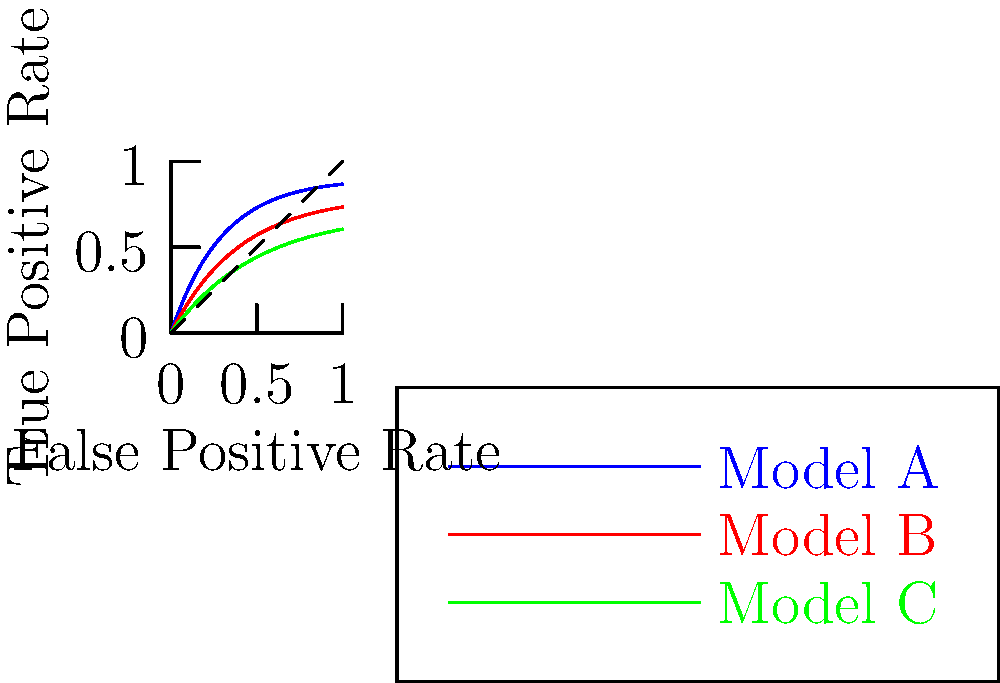Based on the ROC curves shown for three machine learning models (A, B, and C) used in nanomaterial property prediction, which model demonstrates the best overall performance? To determine the best performing model based on ROC curves, we need to follow these steps:

1. Understand ROC curves:
   - ROC curves plot the True Positive Rate (TPR) against the False Positive Rate (FPR).
   - The diagonal line represents random guessing.
   - Curves closer to the top-left corner indicate better performance.

2. Analyze Area Under the Curve (AUC):
   - AUC is a measure of the model's overall performance.
   - A larger AUC indicates better performance.

3. Compare the curves:
   - Model A (blue): Closest to the top-left corner, largest area under the curve.
   - Model B (red): Second best, between A and C.
   - Model C (green): Furthest from the top-left corner, smallest area under the curve.

4. Consider trade-offs:
   - Model A has the highest TPR for any given FPR.
   - This means it correctly identifies more true positives while minimizing false positives.

5. Conclusion:
   Model A demonstrates the best overall performance for nanomaterial property prediction based on its ROC curve.
Answer: Model A 